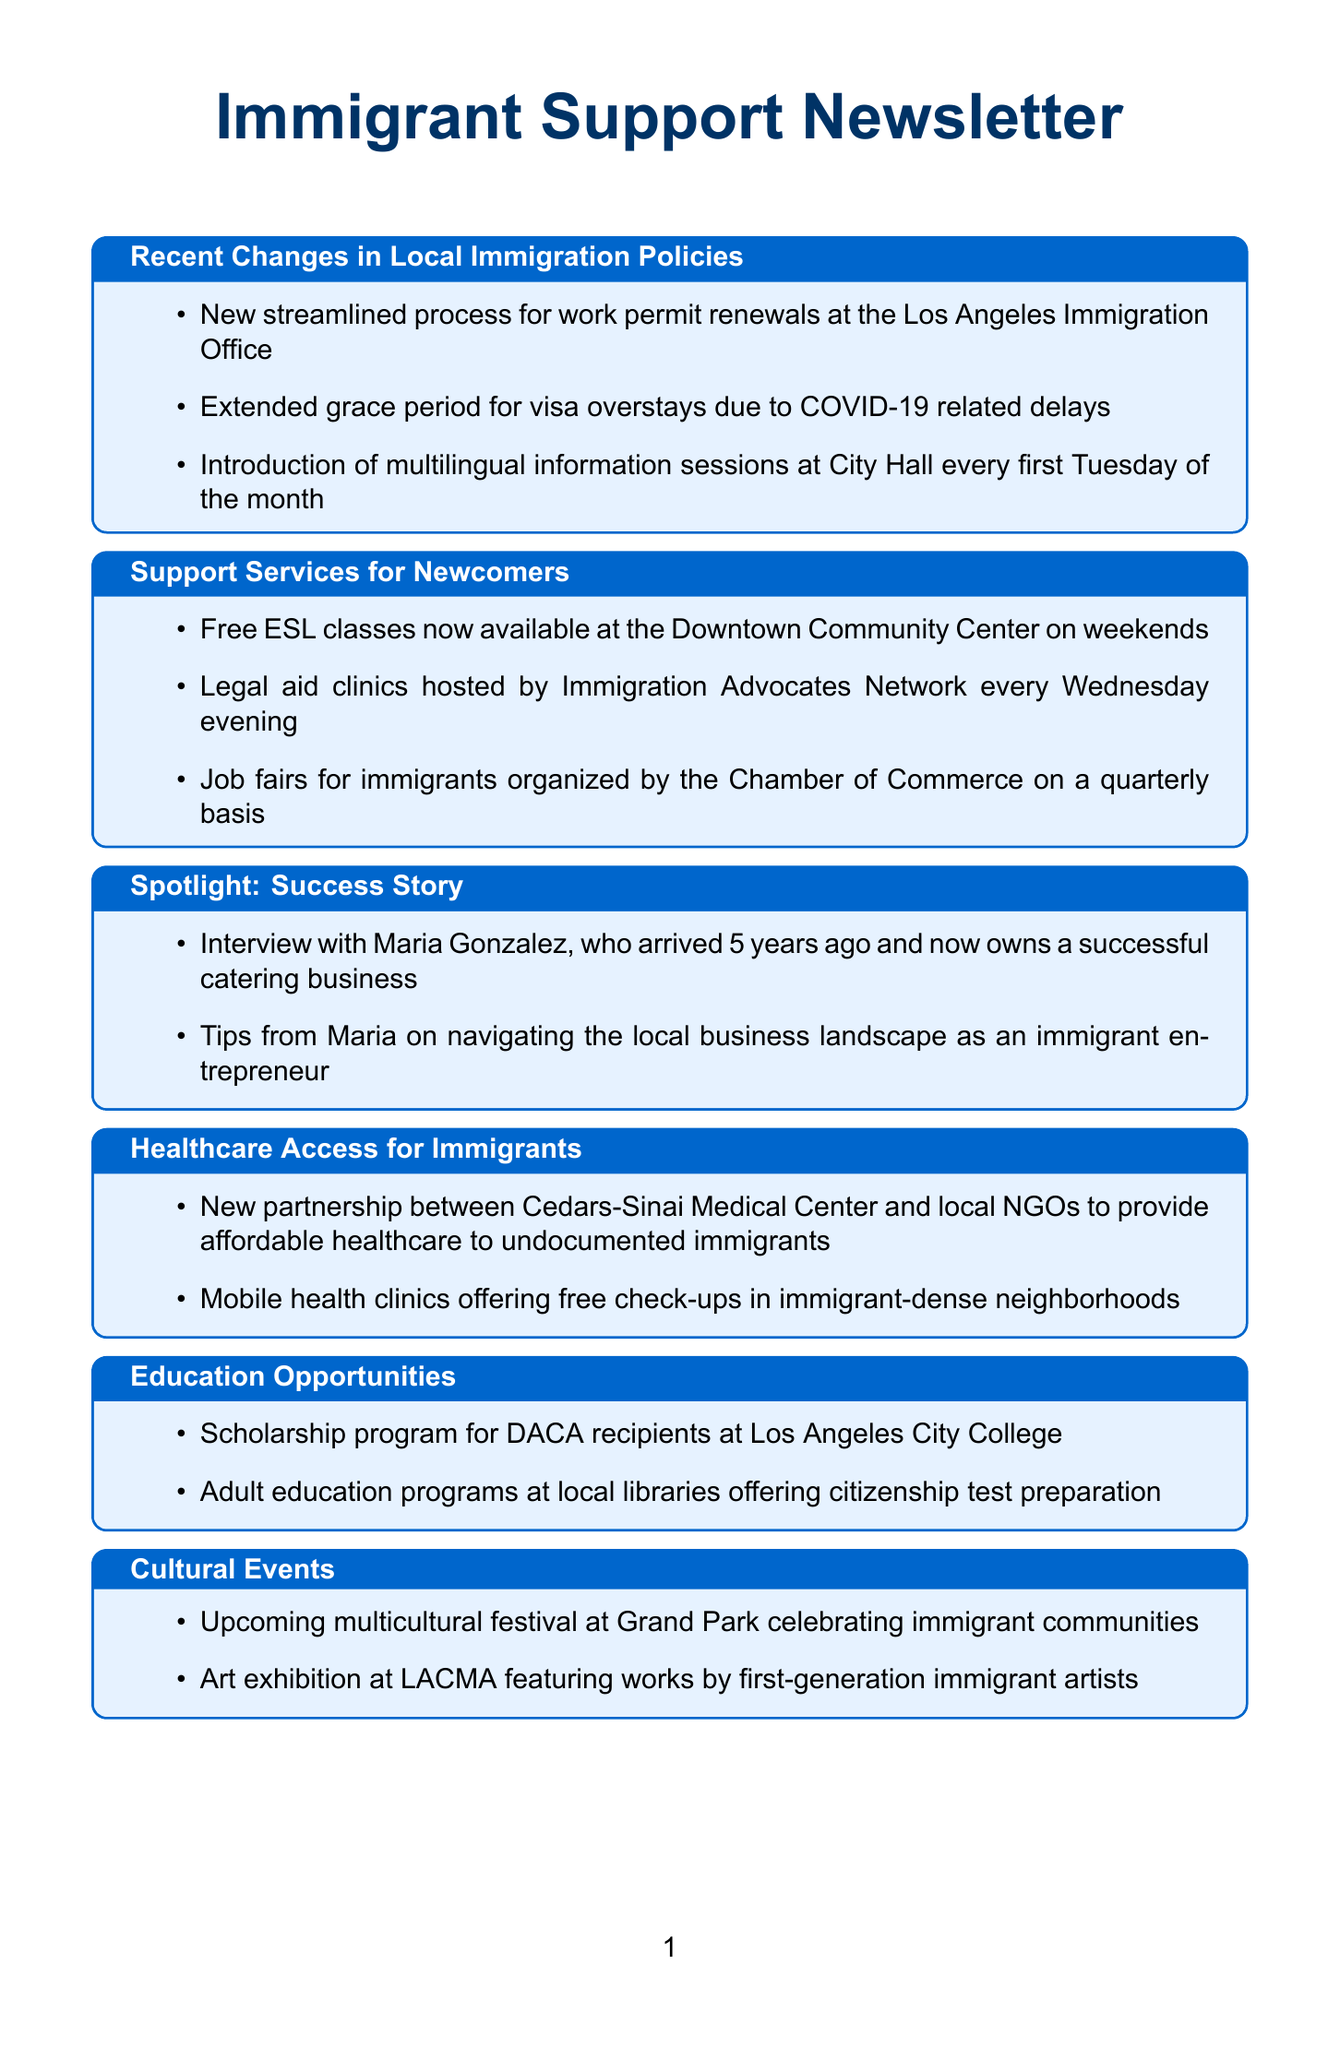What is the new process introduced for work permit renewals? The document states that there is a "New streamlined process for work permit renewals at the Los Angeles Immigration Office."
Answer: Streamlined process What kind of classes are available for newcomers? The newsletter mentions "Free ESL classes" available at the Downtown Community Center on weekends.
Answer: Free ESL classes When do legal aid clinics take place? The document specifies that legal aid clinics are "hosted by Immigration Advocates Network every Wednesday evening."
Answer: Wednesday evening Who is featured in the success story section? The newsletter includes "Interview with Maria Gonzalez," who is highlighted as a success story.
Answer: Maria Gonzalez What healthcare partnership is mentioned for undocumented immigrants? The document refers to a "New partnership between Cedars-Sinai Medical Center and local NGOs" for providing healthcare.
Answer: Cedars-Sinai Medical Center How often are job fairs for immigrants organized? The newsletter notes that job fairs for immigrants are organized "on a quarterly basis."
Answer: Quarterly Which college offers scholarships for DACA recipients? The scholarship program for DACA recipients is available at "Los Angeles City College."
Answer: Los Angeles City College What kind of festival is upcoming at Grand Park? The document mentions an "upcoming multicultural festival" celebrating immigrant communities.
Answer: Multicultural festival What is a resource provided in the Security Guard's Corner? The section includes "Resources for reporting workplace discrimination or unfair treatment."
Answer: Reporting workplace discrimination 